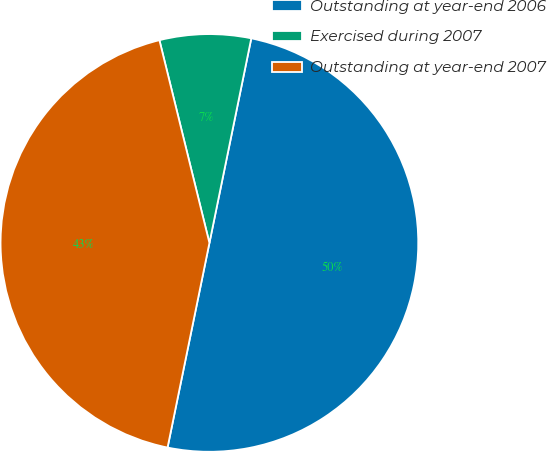Convert chart to OTSL. <chart><loc_0><loc_0><loc_500><loc_500><pie_chart><fcel>Outstanding at year-end 2006<fcel>Exercised during 2007<fcel>Outstanding at year-end 2007<nl><fcel>50.0%<fcel>7.06%<fcel>42.94%<nl></chart> 